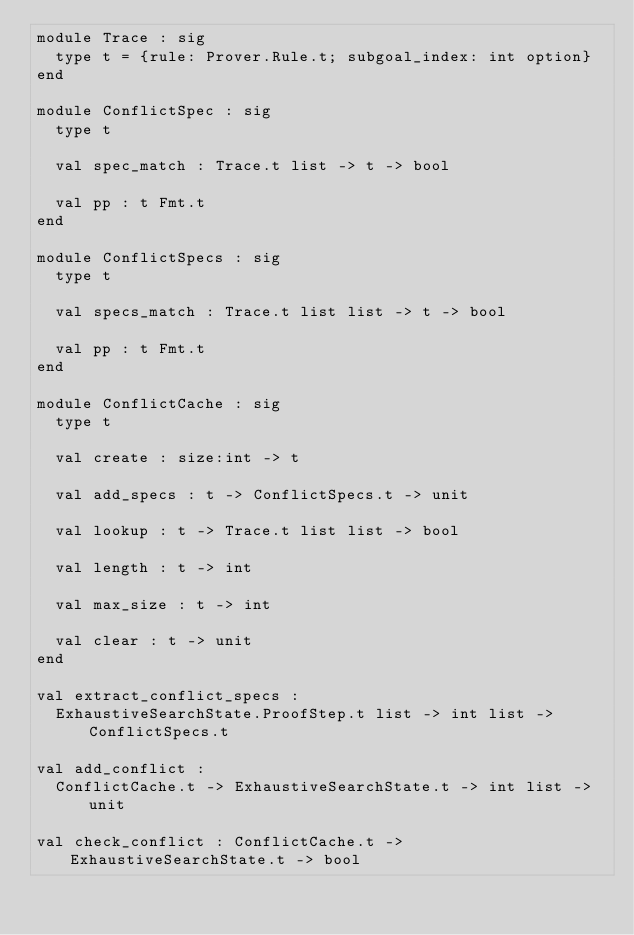<code> <loc_0><loc_0><loc_500><loc_500><_OCaml_>module Trace : sig
  type t = {rule: Prover.Rule.t; subgoal_index: int option}
end

module ConflictSpec : sig
  type t

  val spec_match : Trace.t list -> t -> bool

  val pp : t Fmt.t
end

module ConflictSpecs : sig
  type t

  val specs_match : Trace.t list list -> t -> bool

  val pp : t Fmt.t
end

module ConflictCache : sig
  type t

  val create : size:int -> t

  val add_specs : t -> ConflictSpecs.t -> unit

  val lookup : t -> Trace.t list list -> bool

  val length : t -> int

  val max_size : t -> int

  val clear : t -> unit
end

val extract_conflict_specs :
  ExhaustiveSearchState.ProofStep.t list -> int list -> ConflictSpecs.t

val add_conflict :
  ConflictCache.t -> ExhaustiveSearchState.t -> int list -> unit

val check_conflict : ConflictCache.t -> ExhaustiveSearchState.t -> bool
</code> 